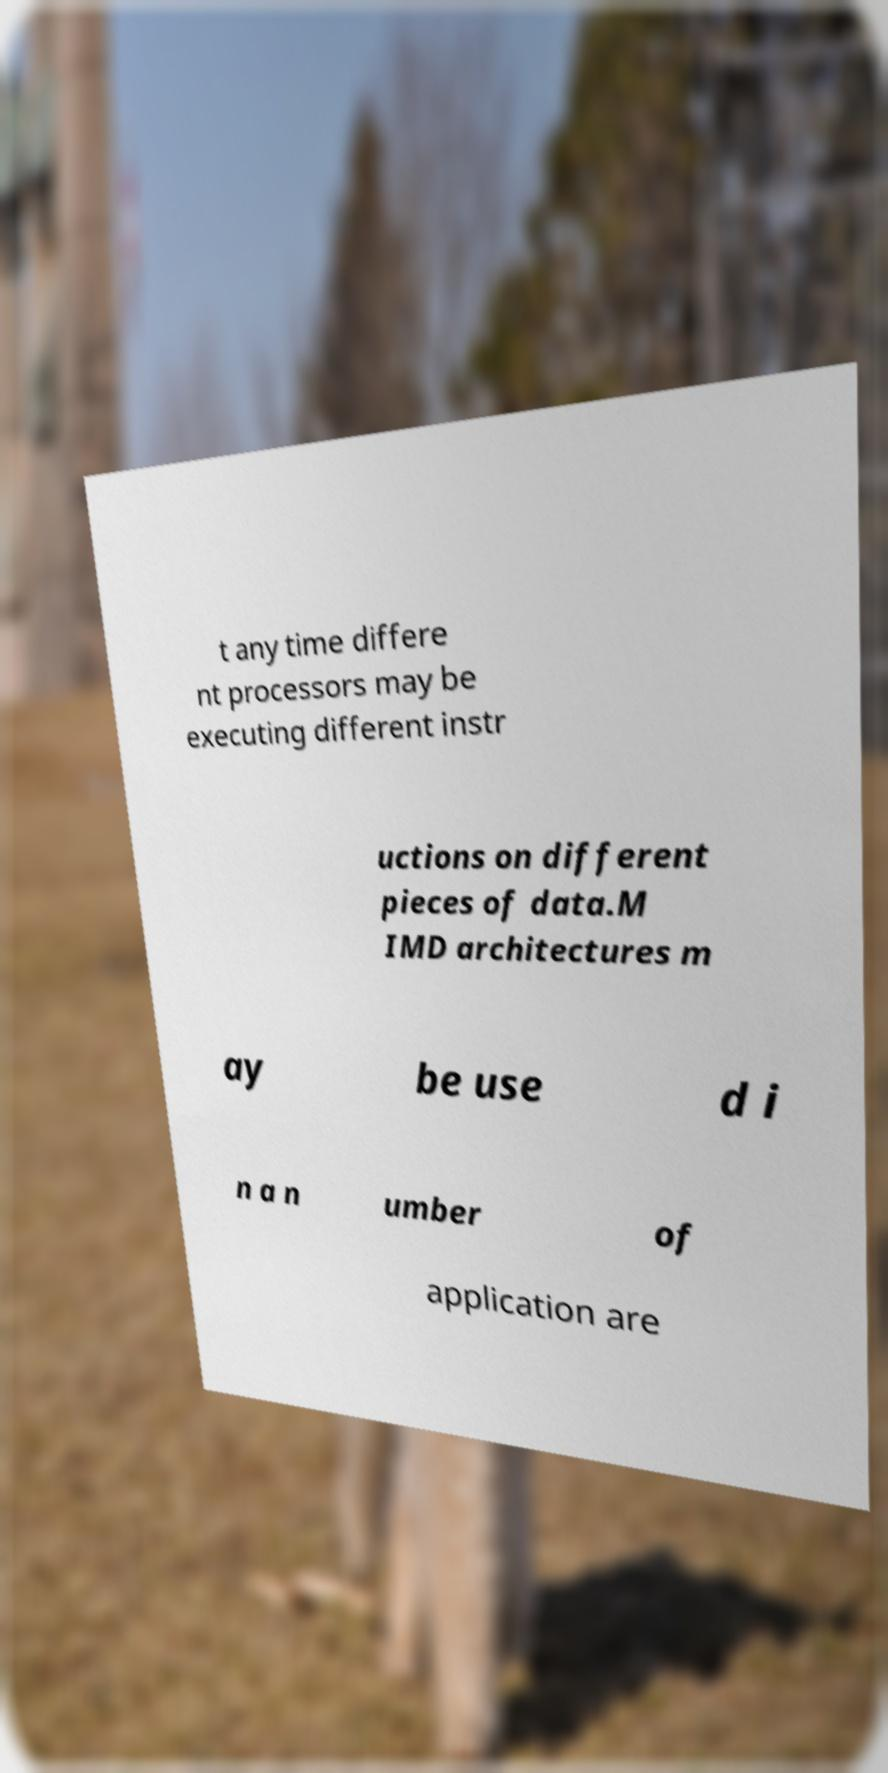Could you extract and type out the text from this image? t any time differe nt processors may be executing different instr uctions on different pieces of data.M IMD architectures m ay be use d i n a n umber of application are 